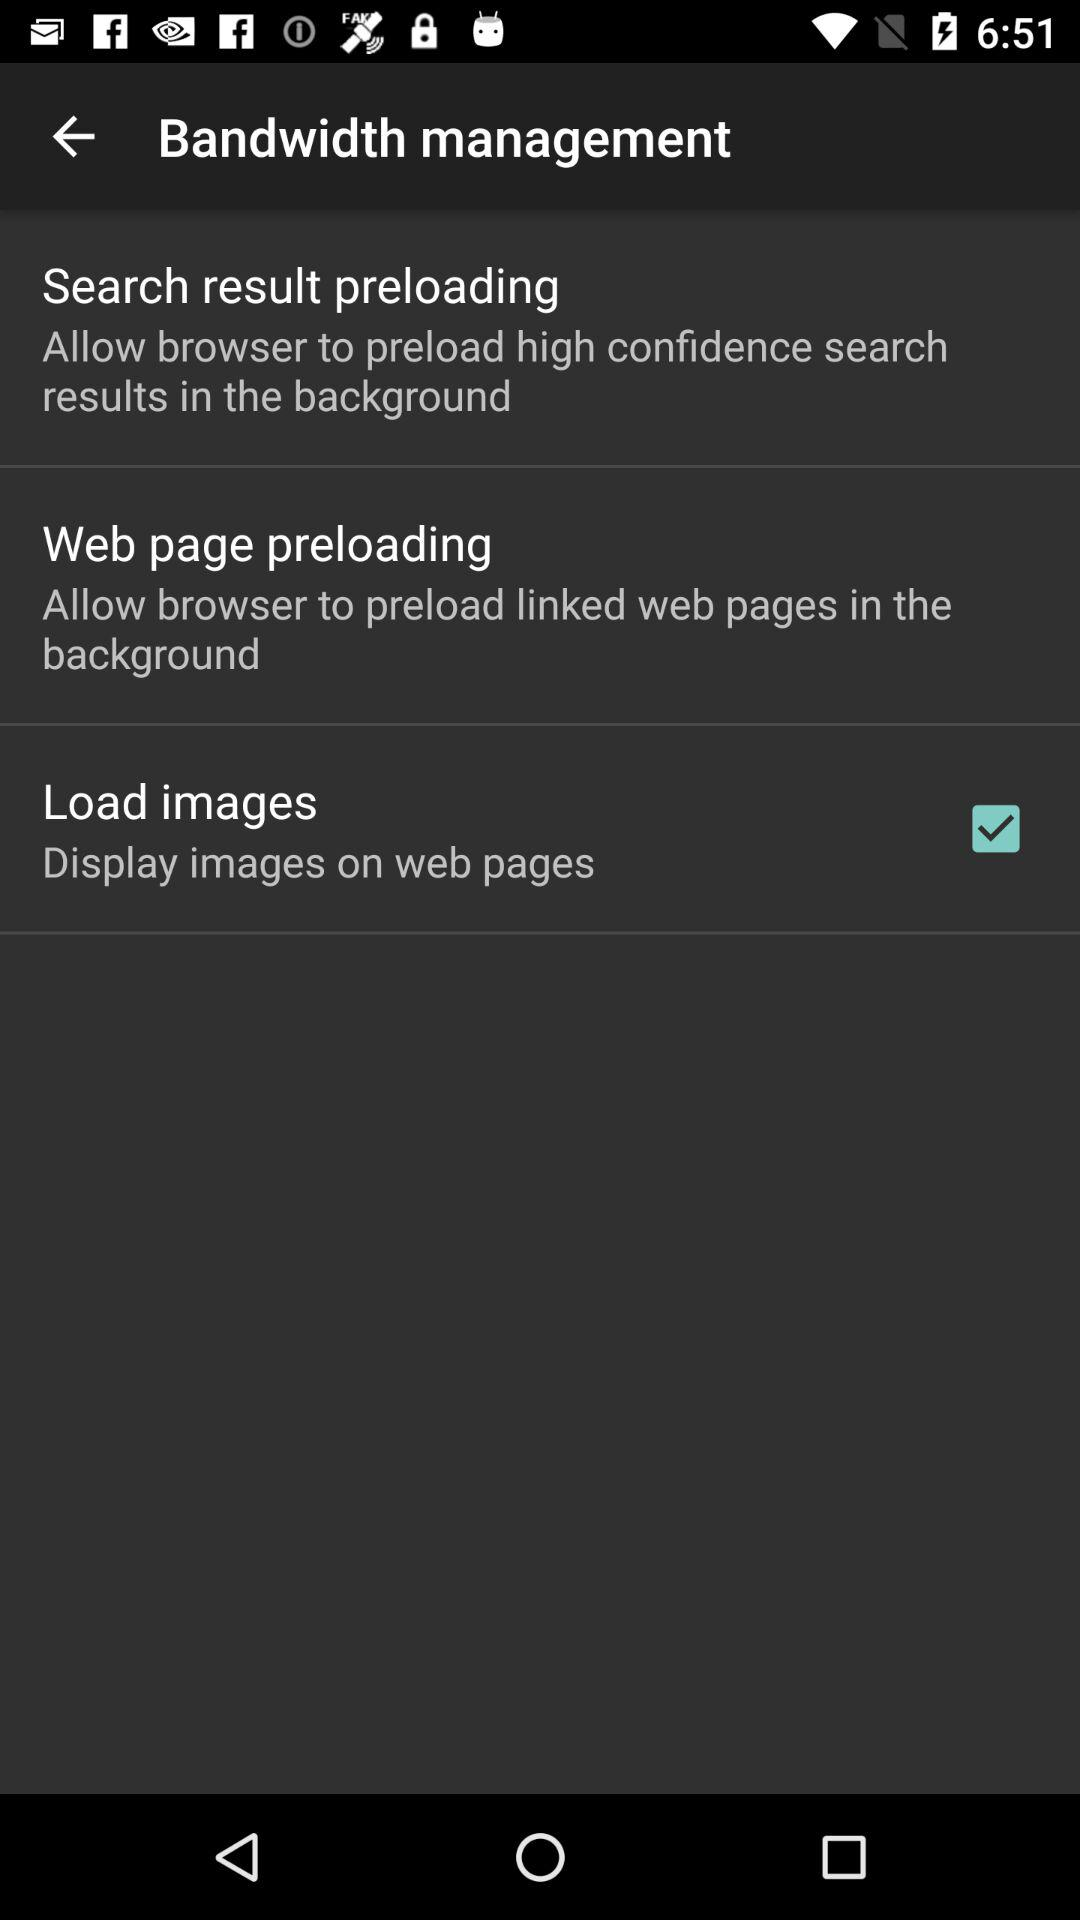How many items are there in the Bandwidth Management section?
Answer the question using a single word or phrase. 3 